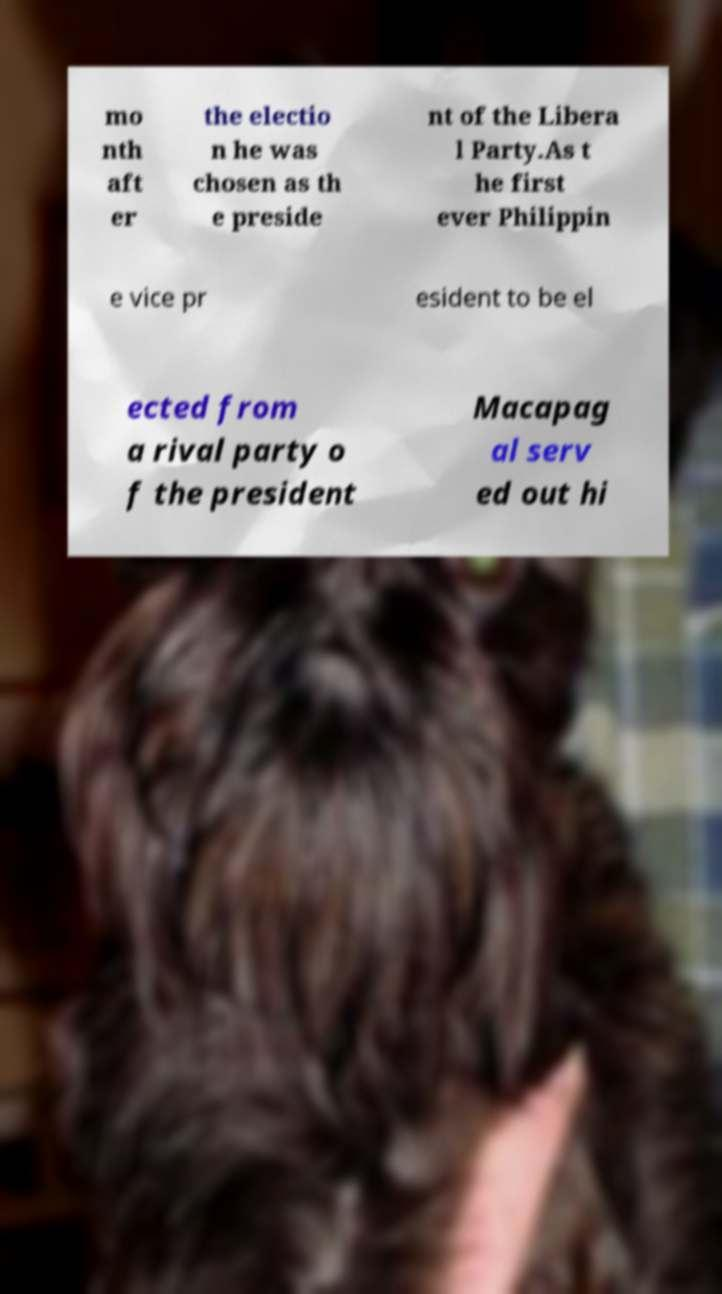Could you extract and type out the text from this image? mo nth aft er the electio n he was chosen as th e preside nt of the Libera l Party.As t he first ever Philippin e vice pr esident to be el ected from a rival party o f the president Macapag al serv ed out hi 